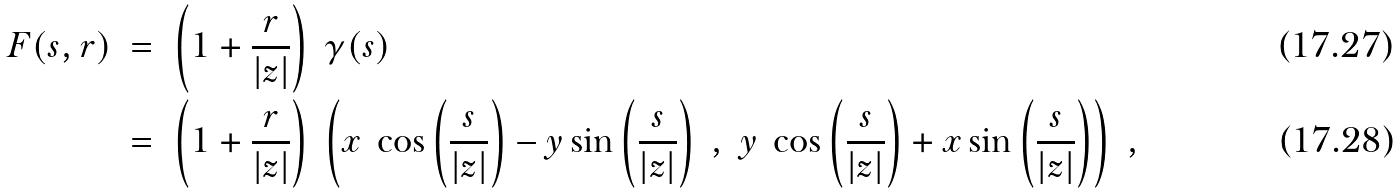Convert formula to latex. <formula><loc_0><loc_0><loc_500><loc_500>F ( s , r ) \ & = \ \left ( 1 + \frac { r } { | z | } \right ) \ \gamma ( s ) \\ & = \ \left ( 1 + \frac { r } { | z | } \right ) \ \left ( x \ \cos \left ( \frac { s } { | z | } \right ) - y \sin \left ( \frac { s } { | z | } \right ) \ , \ y \ \cos \left ( \frac { s } { | z | } \right ) + x \sin \left ( \frac { s } { | z | } \right ) \right ) \ ,</formula> 